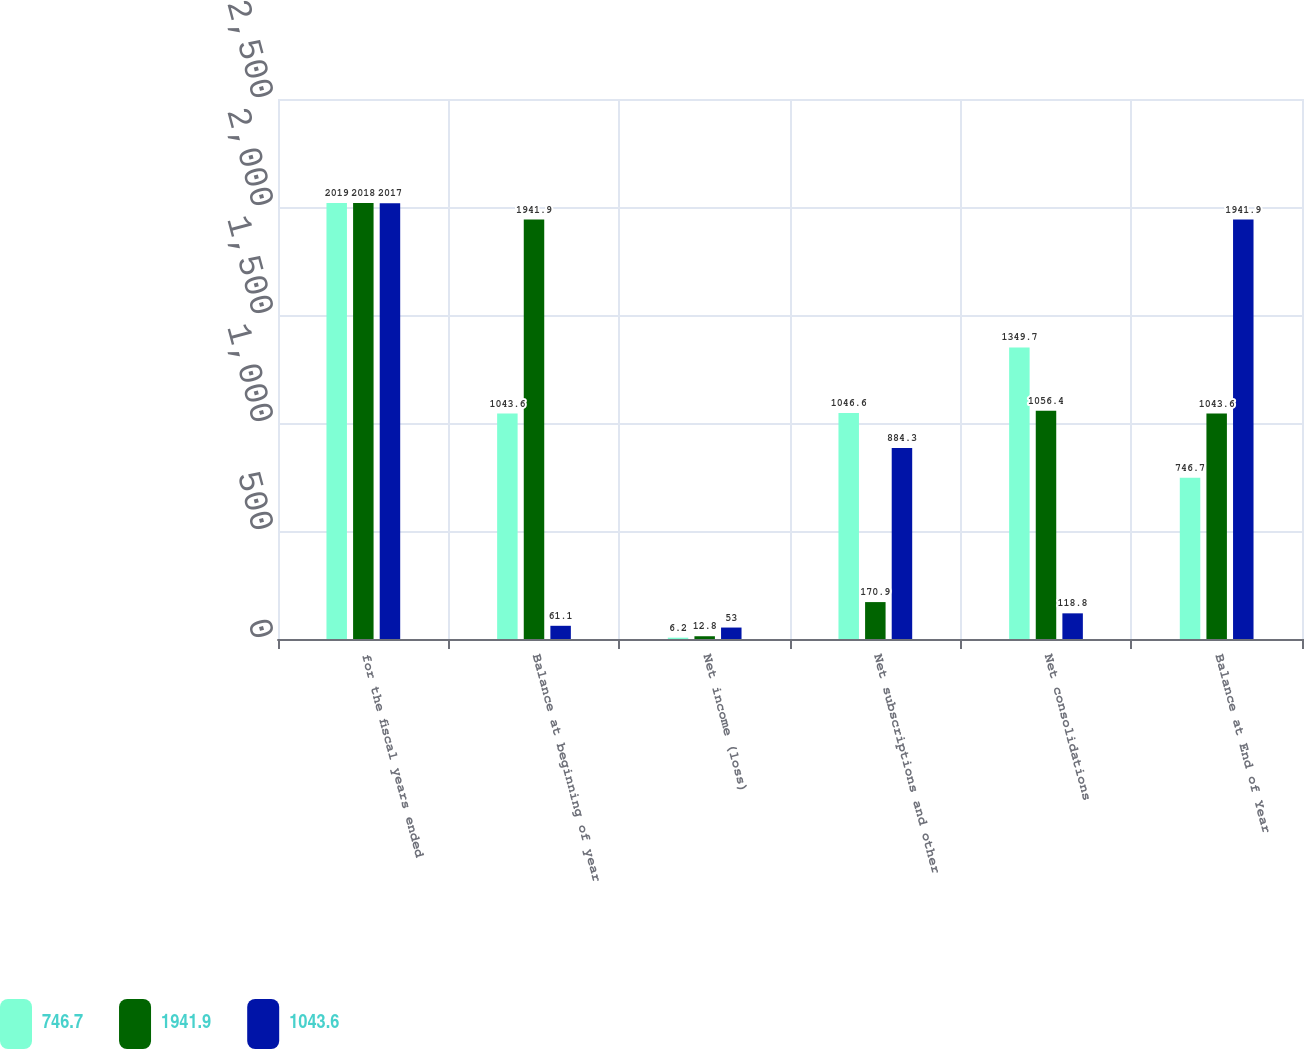Convert chart. <chart><loc_0><loc_0><loc_500><loc_500><stacked_bar_chart><ecel><fcel>for the fiscal years ended<fcel>Balance at beginning of year<fcel>Net income (loss)<fcel>Net subscriptions and other<fcel>Net consolidations<fcel>Balance at End of Year<nl><fcel>746.7<fcel>2019<fcel>1043.6<fcel>6.2<fcel>1046.6<fcel>1349.7<fcel>746.7<nl><fcel>1941.9<fcel>2018<fcel>1941.9<fcel>12.8<fcel>170.9<fcel>1056.4<fcel>1043.6<nl><fcel>1043.6<fcel>2017<fcel>61.1<fcel>53<fcel>884.3<fcel>118.8<fcel>1941.9<nl></chart> 